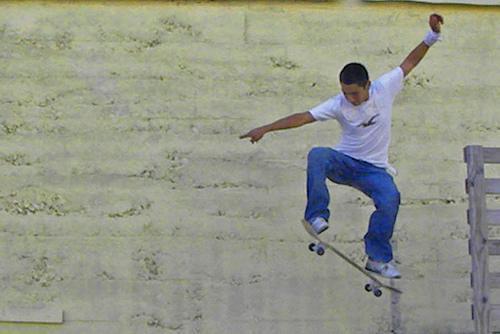How many people?
Give a very brief answer. 1. How many people are bicycling in the picture?
Give a very brief answer. 0. 